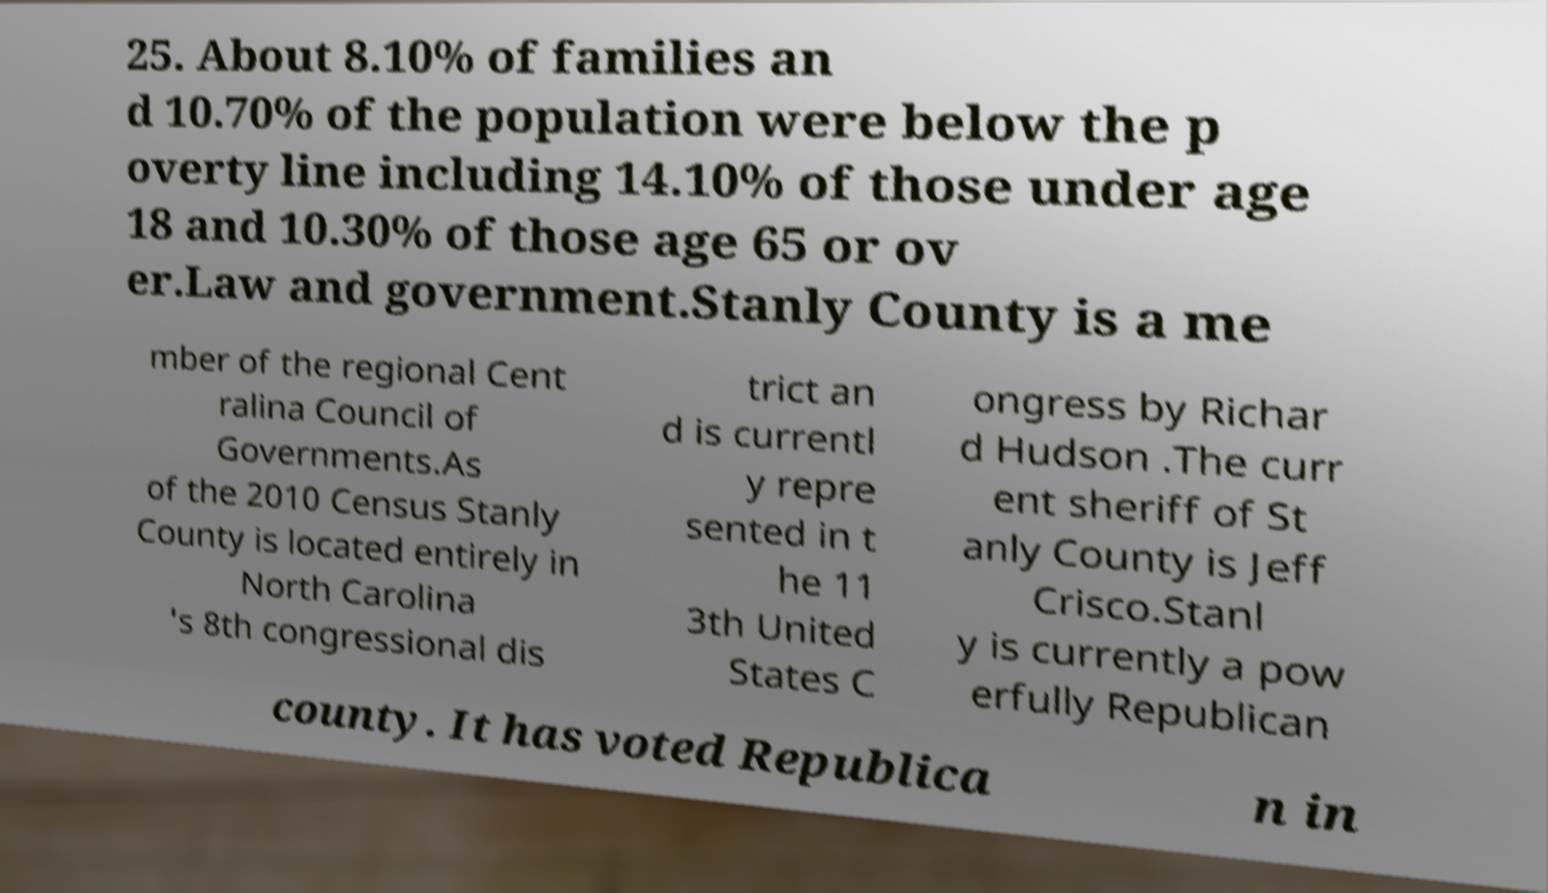What messages or text are displayed in this image? I need them in a readable, typed format. 25. About 8.10% of families an d 10.70% of the population were below the p overty line including 14.10% of those under age 18 and 10.30% of those age 65 or ov er.Law and government.Stanly County is a me mber of the regional Cent ralina Council of Governments.As of the 2010 Census Stanly County is located entirely in North Carolina 's 8th congressional dis trict an d is currentl y repre sented in t he 11 3th United States C ongress by Richar d Hudson .The curr ent sheriff of St anly County is Jeff Crisco.Stanl y is currently a pow erfully Republican county. It has voted Republica n in 